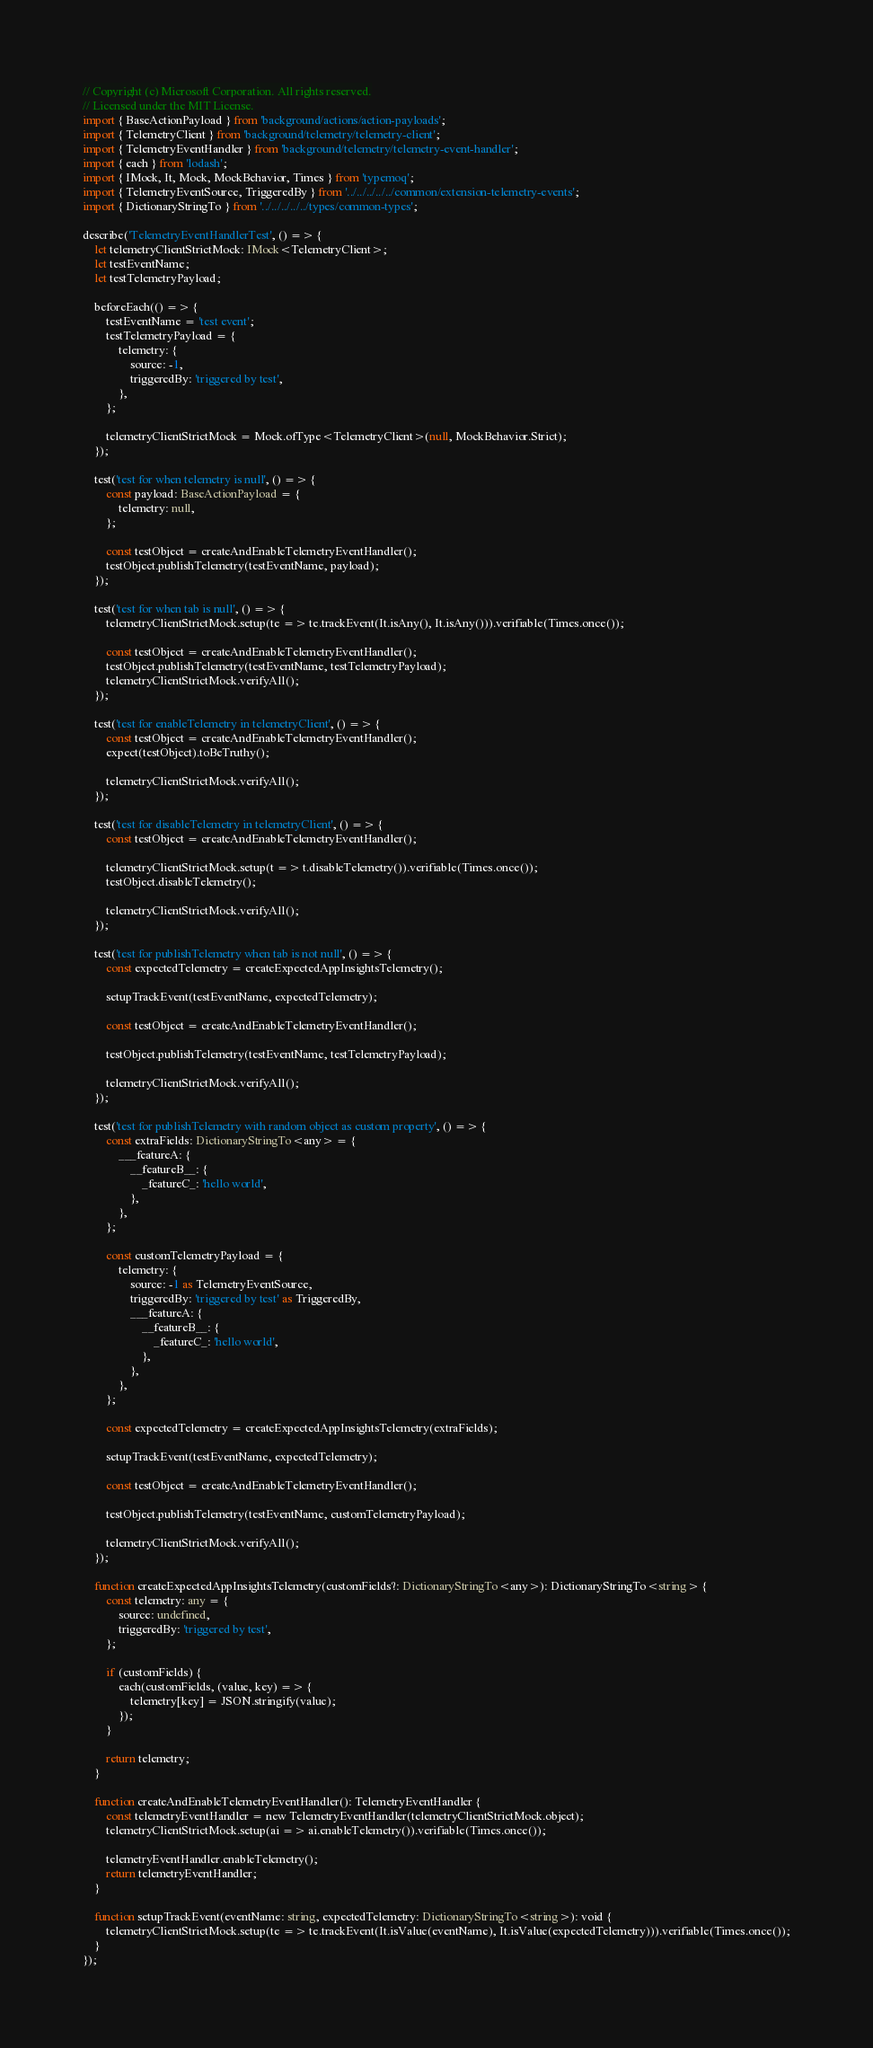Convert code to text. <code><loc_0><loc_0><loc_500><loc_500><_TypeScript_>// Copyright (c) Microsoft Corporation. All rights reserved.
// Licensed under the MIT License.
import { BaseActionPayload } from 'background/actions/action-payloads';
import { TelemetryClient } from 'background/telemetry/telemetry-client';
import { TelemetryEventHandler } from 'background/telemetry/telemetry-event-handler';
import { each } from 'lodash';
import { IMock, It, Mock, MockBehavior, Times } from 'typemoq';
import { TelemetryEventSource, TriggeredBy } from '../../../../../common/extension-telemetry-events';
import { DictionaryStringTo } from '../../../../../types/common-types';

describe('TelemetryEventHandlerTest', () => {
    let telemetryClientStrictMock: IMock<TelemetryClient>;
    let testEventName;
    let testTelemetryPayload;

    beforeEach(() => {
        testEventName = 'test event';
        testTelemetryPayload = {
            telemetry: {
                source: -1,
                triggeredBy: 'triggered by test',
            },
        };

        telemetryClientStrictMock = Mock.ofType<TelemetryClient>(null, MockBehavior.Strict);
    });

    test('test for when telemetry is null', () => {
        const payload: BaseActionPayload = {
            telemetry: null,
        };

        const testObject = createAndEnableTelemetryEventHandler();
        testObject.publishTelemetry(testEventName, payload);
    });

    test('test for when tab is null', () => {
        telemetryClientStrictMock.setup(te => te.trackEvent(It.isAny(), It.isAny())).verifiable(Times.once());

        const testObject = createAndEnableTelemetryEventHandler();
        testObject.publishTelemetry(testEventName, testTelemetryPayload);
        telemetryClientStrictMock.verifyAll();
    });

    test('test for enableTelemetry in telemetryClient', () => {
        const testObject = createAndEnableTelemetryEventHandler();
        expect(testObject).toBeTruthy();

        telemetryClientStrictMock.verifyAll();
    });

    test('test for disableTelemetry in telemetryClient', () => {
        const testObject = createAndEnableTelemetryEventHandler();

        telemetryClientStrictMock.setup(t => t.disableTelemetry()).verifiable(Times.once());
        testObject.disableTelemetry();

        telemetryClientStrictMock.verifyAll();
    });

    test('test for publishTelemetry when tab is not null', () => {
        const expectedTelemetry = createExpectedAppInsightsTelemetry();

        setupTrackEvent(testEventName, expectedTelemetry);

        const testObject = createAndEnableTelemetryEventHandler();

        testObject.publishTelemetry(testEventName, testTelemetryPayload);

        telemetryClientStrictMock.verifyAll();
    });

    test('test for publishTelemetry with random object as custom property', () => {
        const extraFields: DictionaryStringTo<any> = {
            ___featureA: {
                __featureB__: {
                    _featureC_: 'hello world',
                },
            },
        };

        const customTelemetryPayload = {
            telemetry: {
                source: -1 as TelemetryEventSource,
                triggeredBy: 'triggered by test' as TriggeredBy,
                ___featureA: {
                    __featureB__: {
                        _featureC_: 'hello world',
                    },
                },
            },
        };

        const expectedTelemetry = createExpectedAppInsightsTelemetry(extraFields);

        setupTrackEvent(testEventName, expectedTelemetry);

        const testObject = createAndEnableTelemetryEventHandler();

        testObject.publishTelemetry(testEventName, customTelemetryPayload);

        telemetryClientStrictMock.verifyAll();
    });

    function createExpectedAppInsightsTelemetry(customFields?: DictionaryStringTo<any>): DictionaryStringTo<string> {
        const telemetry: any = {
            source: undefined,
            triggeredBy: 'triggered by test',
        };

        if (customFields) {
            each(customFields, (value, key) => {
                telemetry[key] = JSON.stringify(value);
            });
        }

        return telemetry;
    }

    function createAndEnableTelemetryEventHandler(): TelemetryEventHandler {
        const telemetryEventHandler = new TelemetryEventHandler(telemetryClientStrictMock.object);
        telemetryClientStrictMock.setup(ai => ai.enableTelemetry()).verifiable(Times.once());

        telemetryEventHandler.enableTelemetry();
        return telemetryEventHandler;
    }

    function setupTrackEvent(eventName: string, expectedTelemetry: DictionaryStringTo<string>): void {
        telemetryClientStrictMock.setup(te => te.trackEvent(It.isValue(eventName), It.isValue(expectedTelemetry))).verifiable(Times.once());
    }
});
</code> 